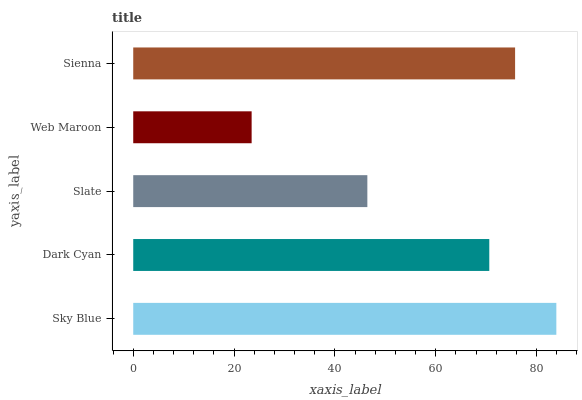Is Web Maroon the minimum?
Answer yes or no. Yes. Is Sky Blue the maximum?
Answer yes or no. Yes. Is Dark Cyan the minimum?
Answer yes or no. No. Is Dark Cyan the maximum?
Answer yes or no. No. Is Sky Blue greater than Dark Cyan?
Answer yes or no. Yes. Is Dark Cyan less than Sky Blue?
Answer yes or no. Yes. Is Dark Cyan greater than Sky Blue?
Answer yes or no. No. Is Sky Blue less than Dark Cyan?
Answer yes or no. No. Is Dark Cyan the high median?
Answer yes or no. Yes. Is Dark Cyan the low median?
Answer yes or no. Yes. Is Slate the high median?
Answer yes or no. No. Is Sky Blue the low median?
Answer yes or no. No. 